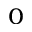Convert formula to latex. <formula><loc_0><loc_0><loc_500><loc_500>_ { 0 }</formula> 